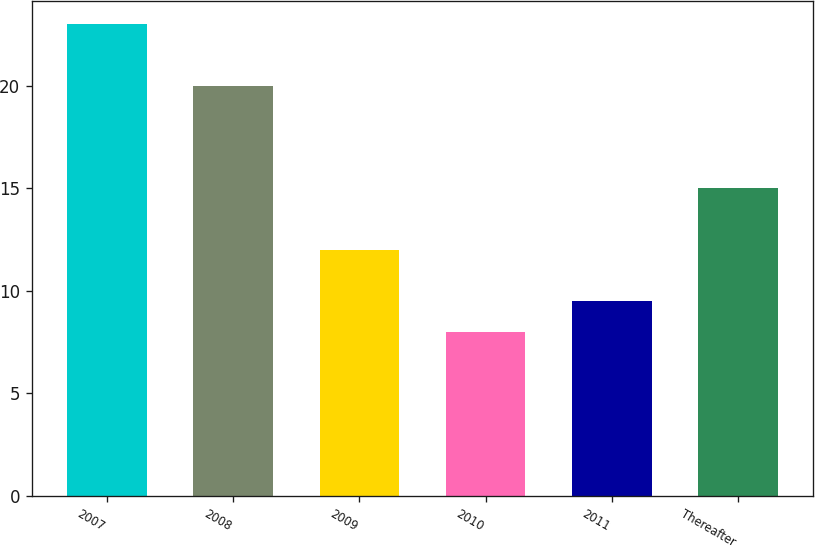Convert chart to OTSL. <chart><loc_0><loc_0><loc_500><loc_500><bar_chart><fcel>2007<fcel>2008<fcel>2009<fcel>2010<fcel>2011<fcel>Thereafter<nl><fcel>23<fcel>20<fcel>12<fcel>8<fcel>9.5<fcel>15<nl></chart> 